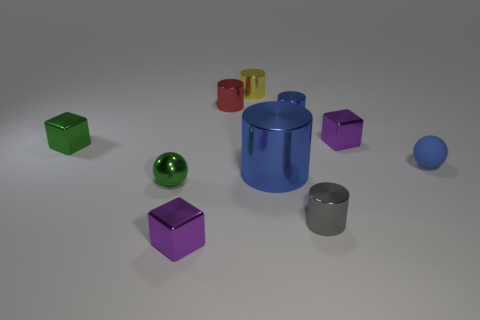Are there fewer small rubber balls than small purple metallic blocks?
Keep it short and to the point. Yes. Does the matte thing have the same size as the metallic thing that is behind the red metallic cylinder?
Your answer should be compact. Yes. How many matte things are tiny objects or small purple cubes?
Keep it short and to the point. 1. Is the number of green balls greater than the number of blocks?
Keep it short and to the point. No. The ball that is the same color as the big thing is what size?
Your answer should be very brief. Small. What is the shape of the small object that is to the right of the tiny block that is right of the red object?
Provide a short and direct response. Sphere. There is a purple object that is on the right side of the purple thing that is in front of the tiny shiny sphere; is there a purple metal cube behind it?
Ensure brevity in your answer.  No. What color is the metal ball that is the same size as the gray thing?
Make the answer very short. Green. What is the shape of the thing that is left of the blue sphere and on the right side of the tiny gray metal thing?
Offer a terse response. Cube. There is a purple metal cube behind the blue cylinder in front of the tiny matte thing; what size is it?
Provide a short and direct response. Small. 